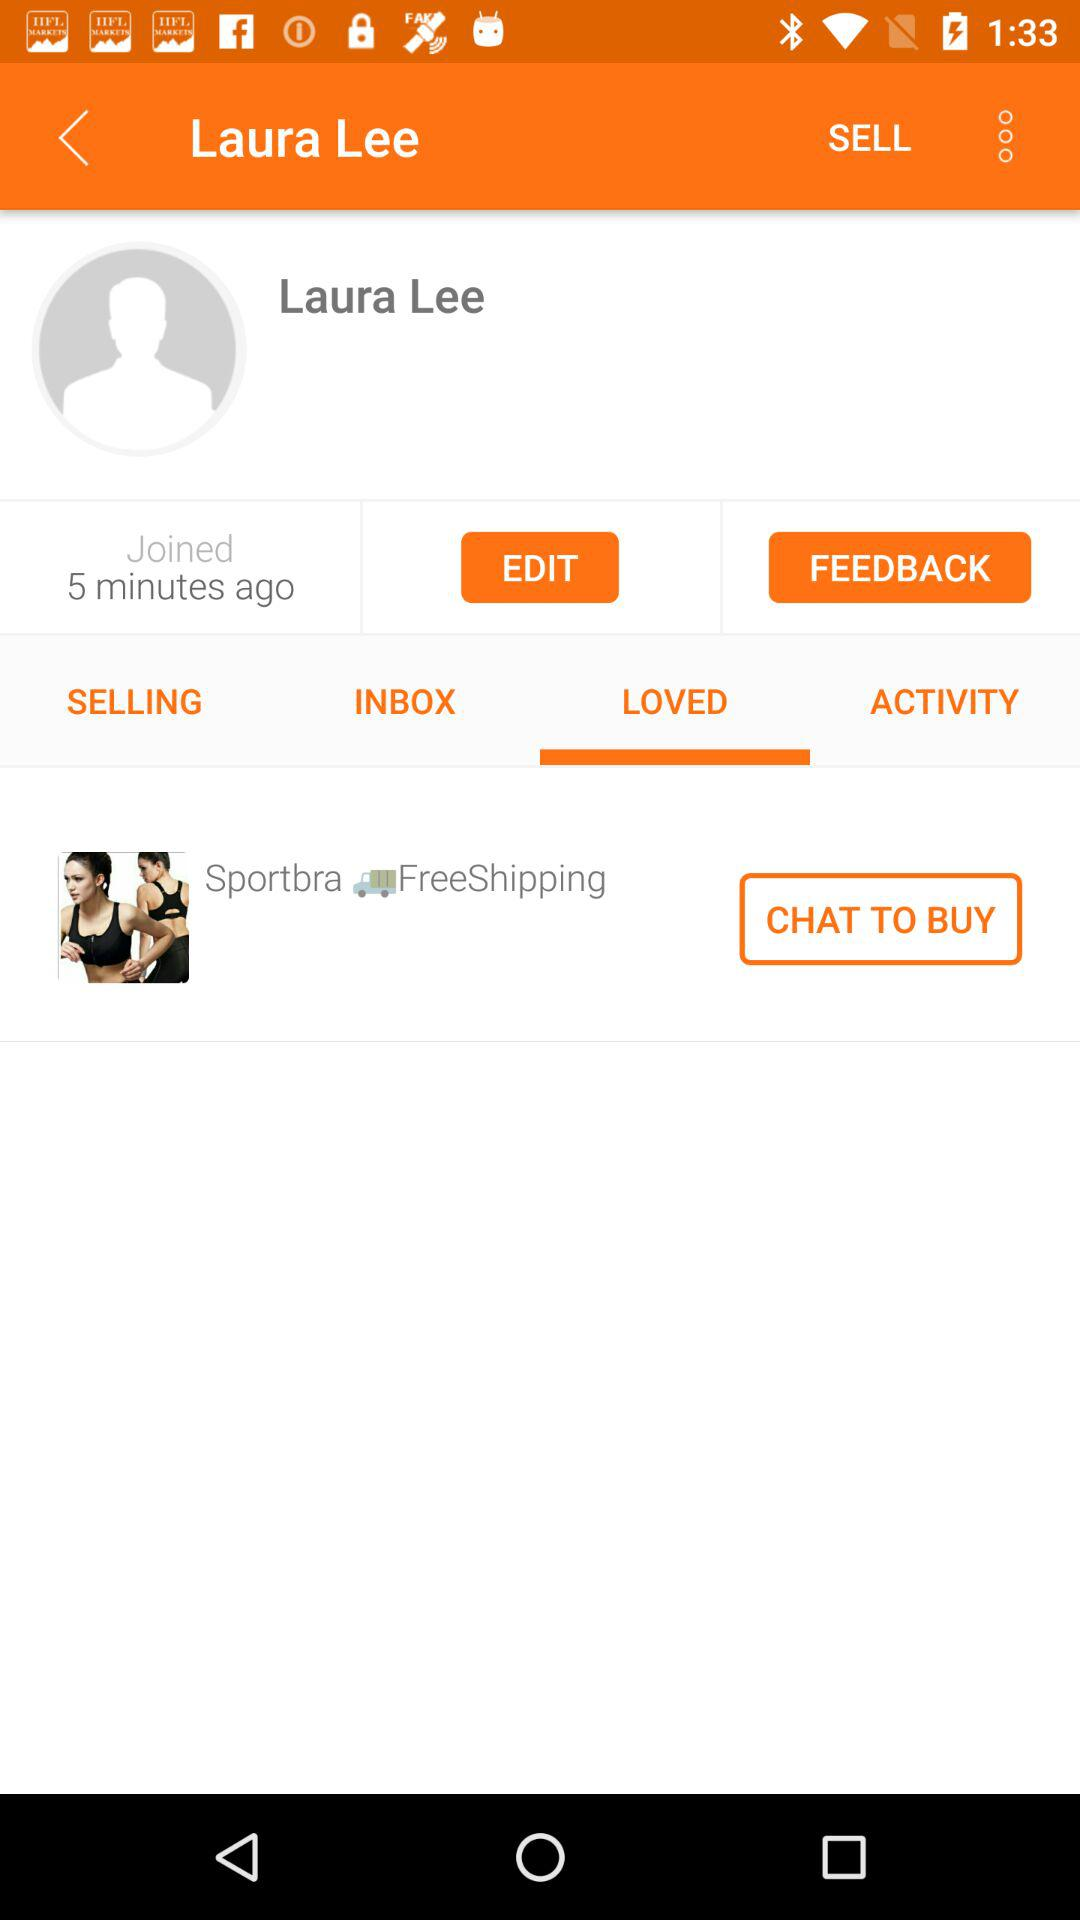When did the user join? The user joined 5 minutes ago. 